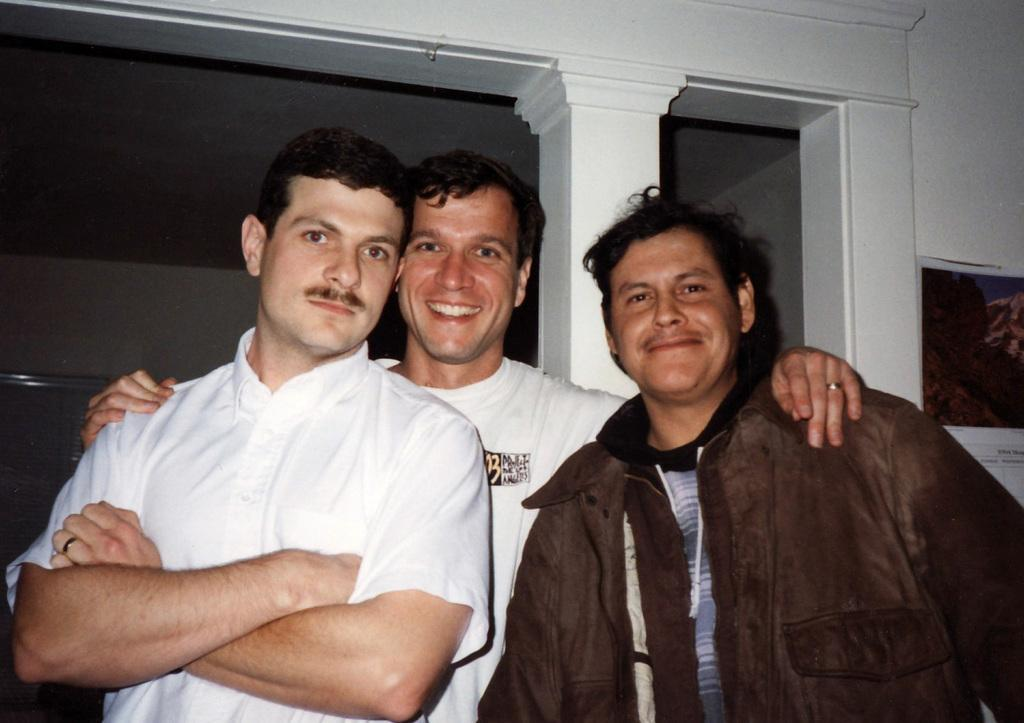How many people are in the image? There are three men in the image. What is the facial expression of the men in the image? The men are smiling. Can you describe the clothing of one of the men? One of the men is wearing a jacket. What can be seen on the wall in the image? There is a poster on the wall in the image. What type of scissors is the stranger using to cut the poster in the image? There is no stranger present in the image, nor is anyone cutting the poster. 